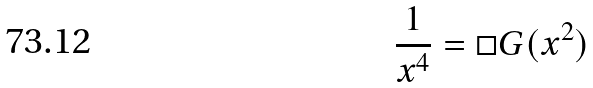<formula> <loc_0><loc_0><loc_500><loc_500>\frac { 1 } { x ^ { 4 } } = \square G ( x ^ { 2 } )</formula> 